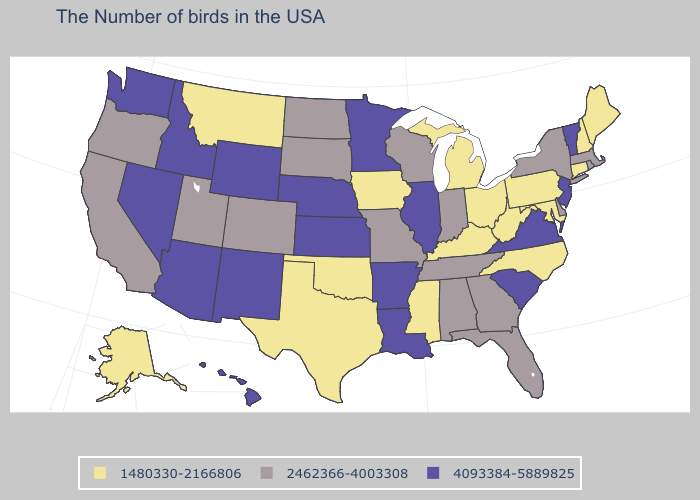What is the lowest value in the West?
Concise answer only. 1480330-2166806. Name the states that have a value in the range 1480330-2166806?
Concise answer only. Maine, New Hampshire, Connecticut, Maryland, Pennsylvania, North Carolina, West Virginia, Ohio, Michigan, Kentucky, Mississippi, Iowa, Oklahoma, Texas, Montana, Alaska. Among the states that border Delaware , does New Jersey have the highest value?
Quick response, please. Yes. Name the states that have a value in the range 2462366-4003308?
Quick response, please. Massachusetts, Rhode Island, New York, Delaware, Florida, Georgia, Indiana, Alabama, Tennessee, Wisconsin, Missouri, South Dakota, North Dakota, Colorado, Utah, California, Oregon. What is the value of Michigan?
Give a very brief answer. 1480330-2166806. Does Nevada have the same value as New Jersey?
Short answer required. Yes. What is the highest value in the USA?
Keep it brief. 4093384-5889825. Does Ohio have the highest value in the MidWest?
Answer briefly. No. What is the value of Montana?
Be succinct. 1480330-2166806. Among the states that border New Hampshire , does Massachusetts have the lowest value?
Give a very brief answer. No. Does the first symbol in the legend represent the smallest category?
Answer briefly. Yes. Among the states that border Kansas , does Nebraska have the lowest value?
Give a very brief answer. No. Which states have the highest value in the USA?
Answer briefly. Vermont, New Jersey, Virginia, South Carolina, Illinois, Louisiana, Arkansas, Minnesota, Kansas, Nebraska, Wyoming, New Mexico, Arizona, Idaho, Nevada, Washington, Hawaii. What is the value of Washington?
Concise answer only. 4093384-5889825. 